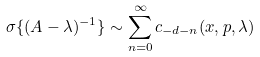<formula> <loc_0><loc_0><loc_500><loc_500>\sigma \{ ( A - \lambda ) ^ { - 1 } \} \sim \sum _ { n = 0 } ^ { \infty } c _ { - d - n } ( x , p , \lambda ) \,</formula> 